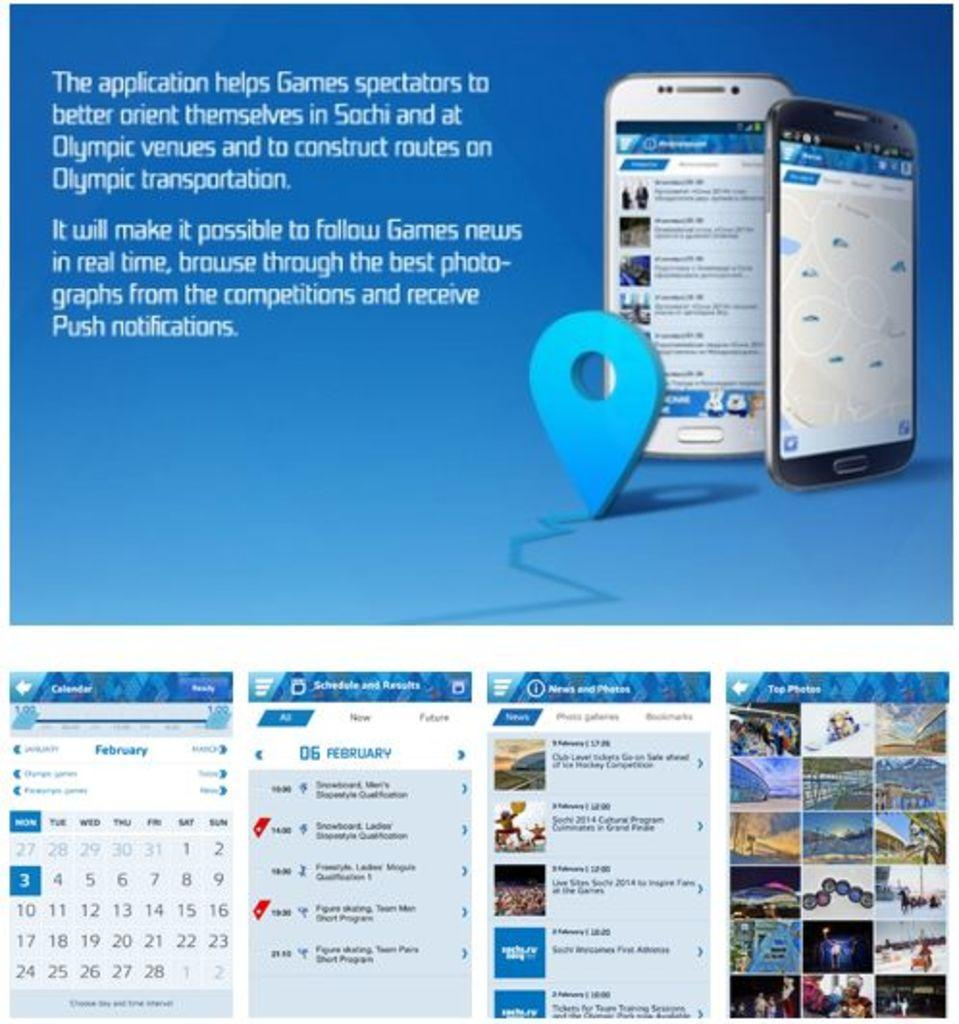<image>
Give a short and clear explanation of the subsequent image. A web page showing smart phones and the two words of the information saying The application. 